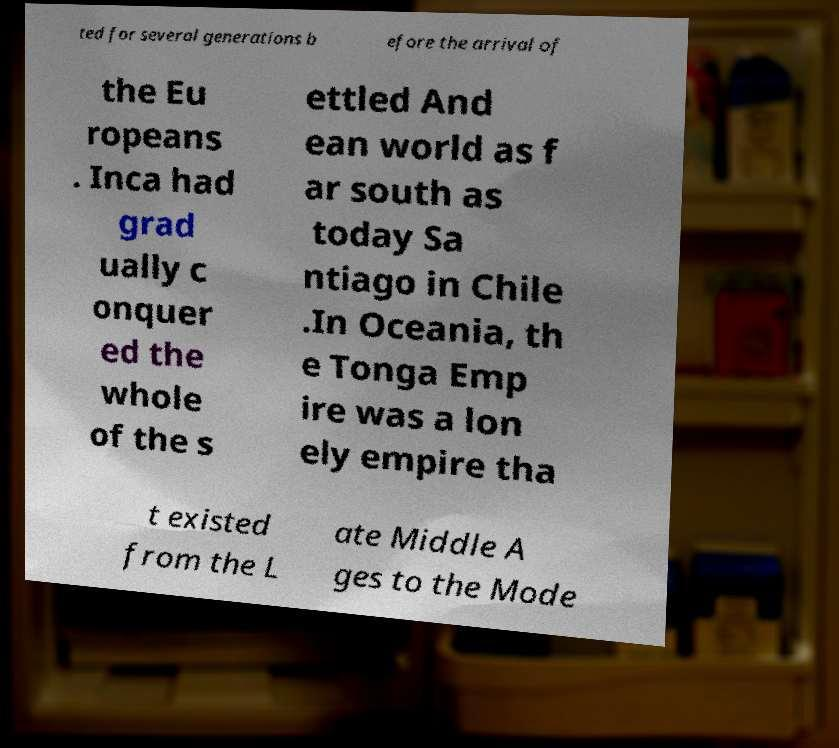Could you extract and type out the text from this image? ted for several generations b efore the arrival of the Eu ropeans . Inca had grad ually c onquer ed the whole of the s ettled And ean world as f ar south as today Sa ntiago in Chile .In Oceania, th e Tonga Emp ire was a lon ely empire tha t existed from the L ate Middle A ges to the Mode 